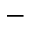<formula> <loc_0><loc_0><loc_500><loc_500>-</formula> 